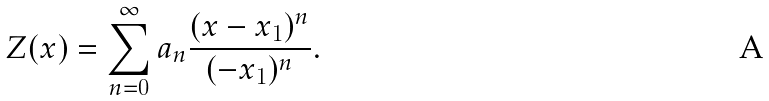<formula> <loc_0><loc_0><loc_500><loc_500>Z ( x ) = \sum _ { n = 0 } ^ { \infty } a _ { n } \frac { ( x - x _ { 1 } ) ^ { n } } { ( - x _ { 1 } ) ^ { n } } .</formula> 